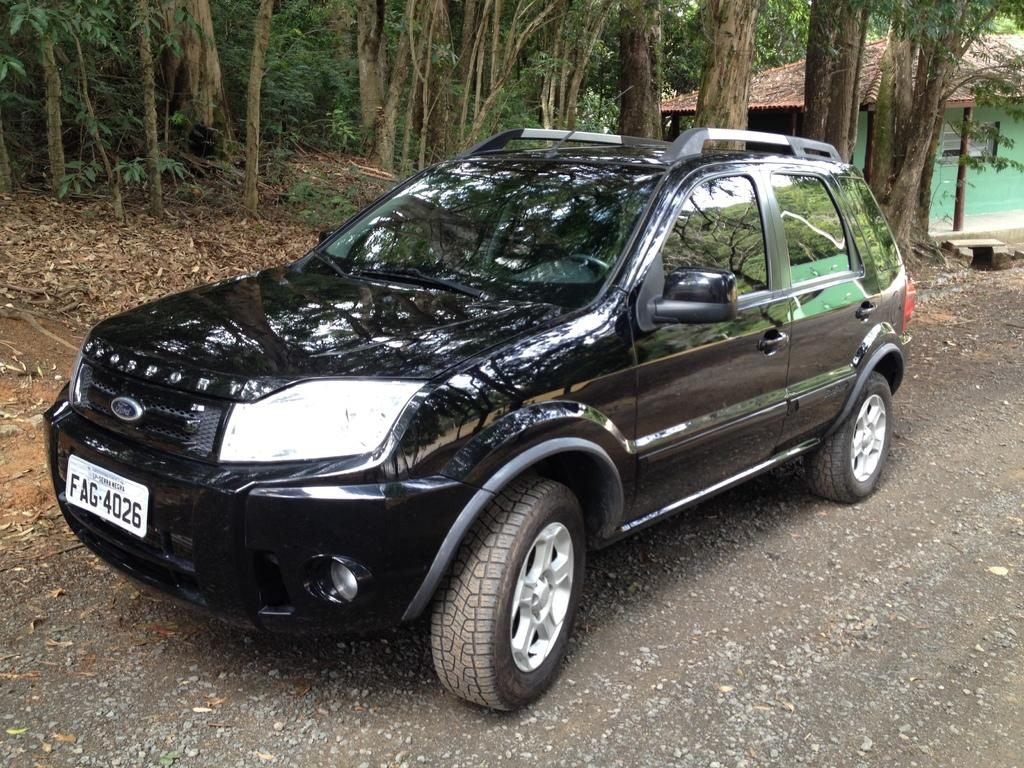What color is the car in the image? The car in the image is black. Where is the car located in the image? The car is on the road. What can be seen in the background of the image? There are many trees in the background of the image. What structure is on the right side of the image? There is a house on the right side of the image. What type of account does the farmer have with the power company in the image? There is no farmer or power company present in the image; it features a black car on the road with a house and trees in the background. 